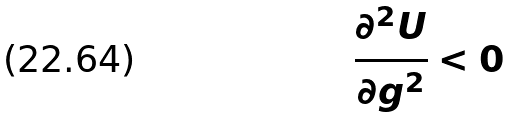Convert formula to latex. <formula><loc_0><loc_0><loc_500><loc_500>\frac { \partial ^ { 2 } U } { \partial g ^ { 2 } } < 0</formula> 